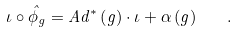<formula> <loc_0><loc_0><loc_500><loc_500>\iota \circ \hat { \phi } _ { g } = A d ^ { * } \left ( g \right ) \cdot \iota + \alpha \left ( g \right ) \quad .</formula> 